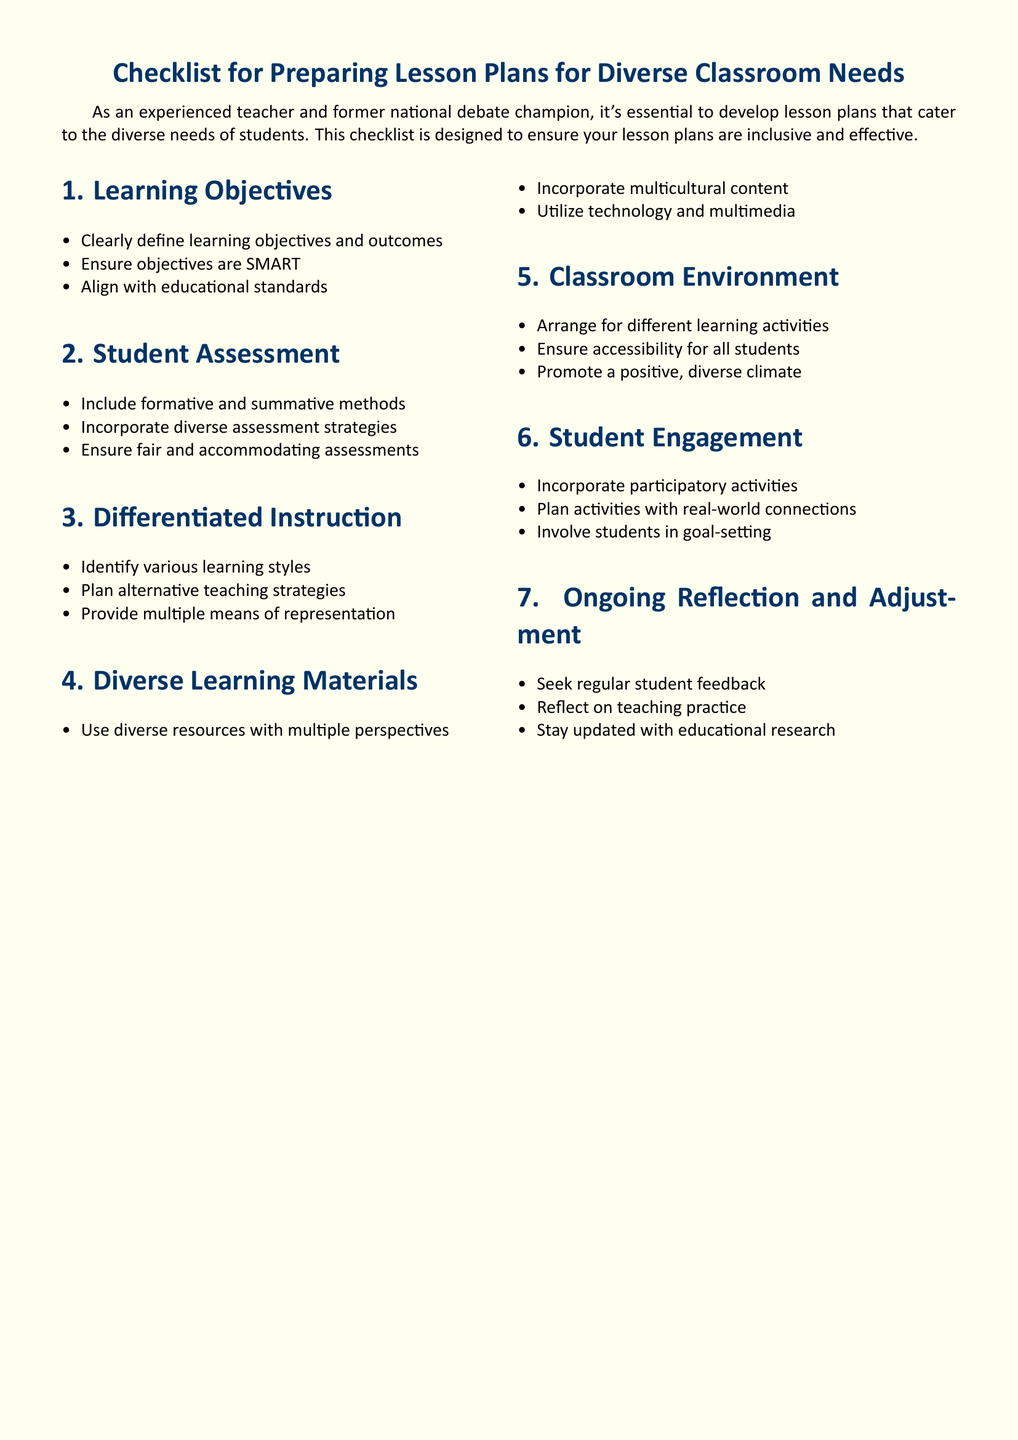What are the three components of Learning Objectives? The document specifies that learning objectives must be clearly defined, SMART, and aligned with educational standards.
Answer: Clearly define learning objectives and outcomes, Ensure objectives are SMART, Align with educational standards What type of assessment methods are included? The checklist states that both formative and summative methods should be included in the assessment process.
Answer: Formative and summative methods What does differentiated instruction aim to identify? The document highlights the need to identify various learning styles in the context of differentiated instruction.
Answer: Various learning styles What types of materials should be utilized? The checklist emphasizes using diverse resources, incorporating multicultural content, and utilizing technology and multimedia.
Answer: Diverse resources with multiple perspectives, Incorporate multicultural content, Utilize technology and multimedia How many sections are in the checklist? The checklist has seven sections covering different aspects of lesson planning for diverse classroom needs.
Answer: Seven What should be incorporated to promote student engagement? The checklist suggests incorporating participatory activities and planning real-world connection activities to promote engagement.
Answer: Incorporate participatory activities, Plan activities with real-world connections How often should ongoing reflection occur? The document suggests seeking regular student feedback and reflecting on one’s teaching practice as part of ongoing reflection.
Answer: Regularly 